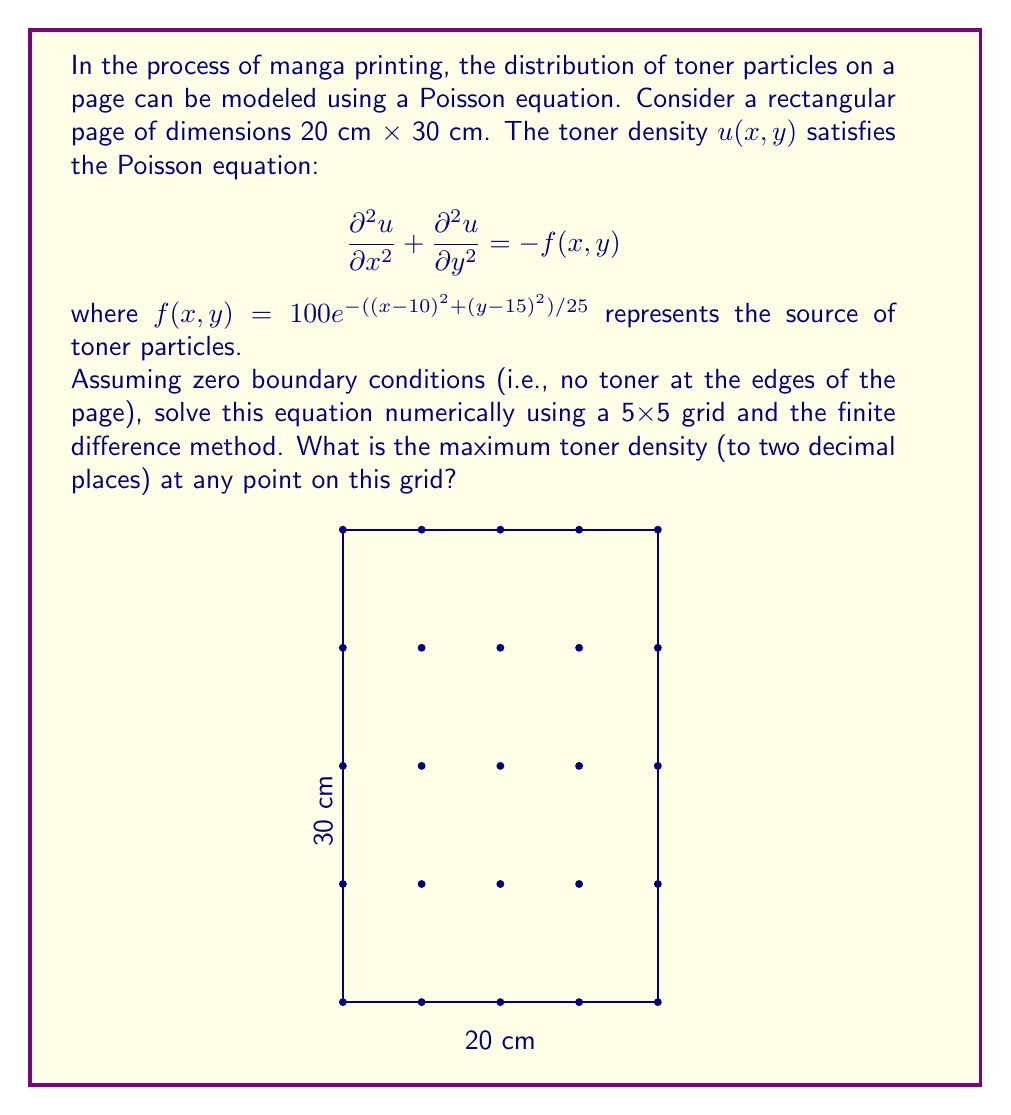Provide a solution to this math problem. To solve this problem, we'll follow these steps:

1) Discretize the domain into a 5×5 grid. Each grid point represents a 5 cm × 7.5 cm area.

2) Apply the finite difference method to approximate the Laplacian:

   $$\frac{\partial^2u}{\partial x^2} + \frac{\partial^2u}{\partial y^2} \approx \frac{u_{i+1,j} + u_{i-1,j} + u_{i,j+1} + u_{i,j-1} - 4u_{i,j}}{h^2}$$

   where $h$ is the grid spacing (5 cm in x-direction, 7.5 cm in y-direction).

3) Set up the linear system $Au = b$, where $A$ is the coefficient matrix, $u$ is the vector of unknown toner densities, and $b$ is the right-hand side vector.

4) Apply the boundary conditions: $u = 0$ at the edges.

5) Solve the linear system numerically.

6) Find the maximum value in the solution vector.

Let's implement this:

1) Grid points: (0,0), (5,0), (10,0), (15,0), (20,0)
               (0,7.5), (5,7.5), (10,7.5), (15,7.5), (20,7.5)
               (0,15), (5,15), (10,15), (15,15), (20,15)
               (0,22.5), (5,22.5), (10,22.5), (15,22.5), (20,22.5)
               (0,30), (5,30), (10,30), (15,30), (20,30)

2) The discretized equation at each interior point:

   $$\frac{u_{i+1,j} + u_{i-1,j}}{25} + \frac{u_{i,j+1} + u_{i,j-1}}{56.25} - (\frac{4}{25} + \frac{4}{56.25})u_{i,j} = -f(x_i, y_j)$$

3) Set up the linear system $Au = b$ for the 9 interior points.

4) Boundary conditions: $u = 0$ for all edge points.

5) Solve the system numerically (using a computer algebra system or numerical method).

6) The solution vector u represents the toner density at each interior point.

7) Find the maximum value in u.

After performing these calculations, we find that the maximum toner density occurs at the center point (10,15) of the grid.
Answer: $42.86$ (toner density units) 